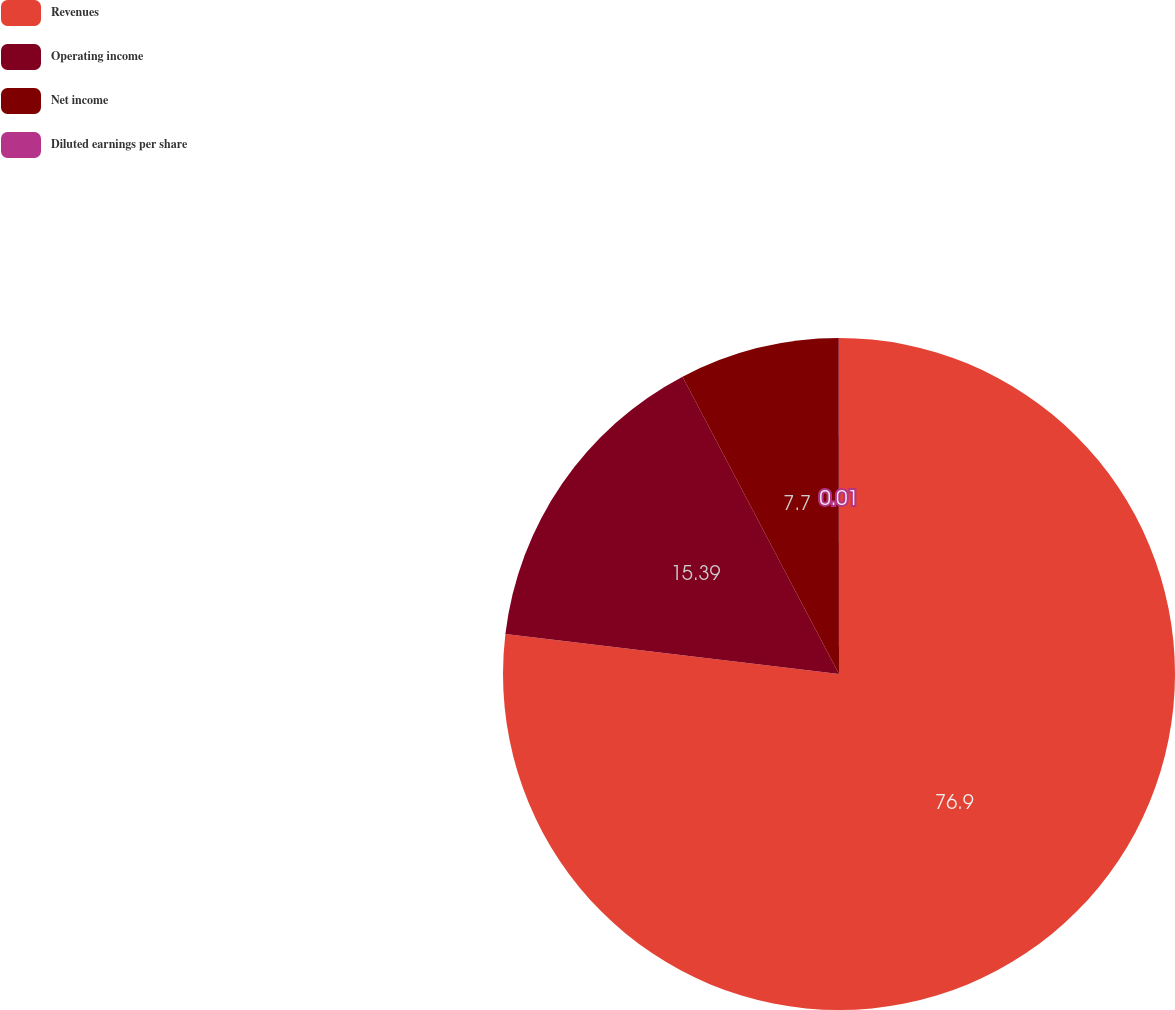Convert chart. <chart><loc_0><loc_0><loc_500><loc_500><pie_chart><fcel>Revenues<fcel>Operating income<fcel>Net income<fcel>Diluted earnings per share<nl><fcel>76.91%<fcel>15.39%<fcel>7.7%<fcel>0.01%<nl></chart> 